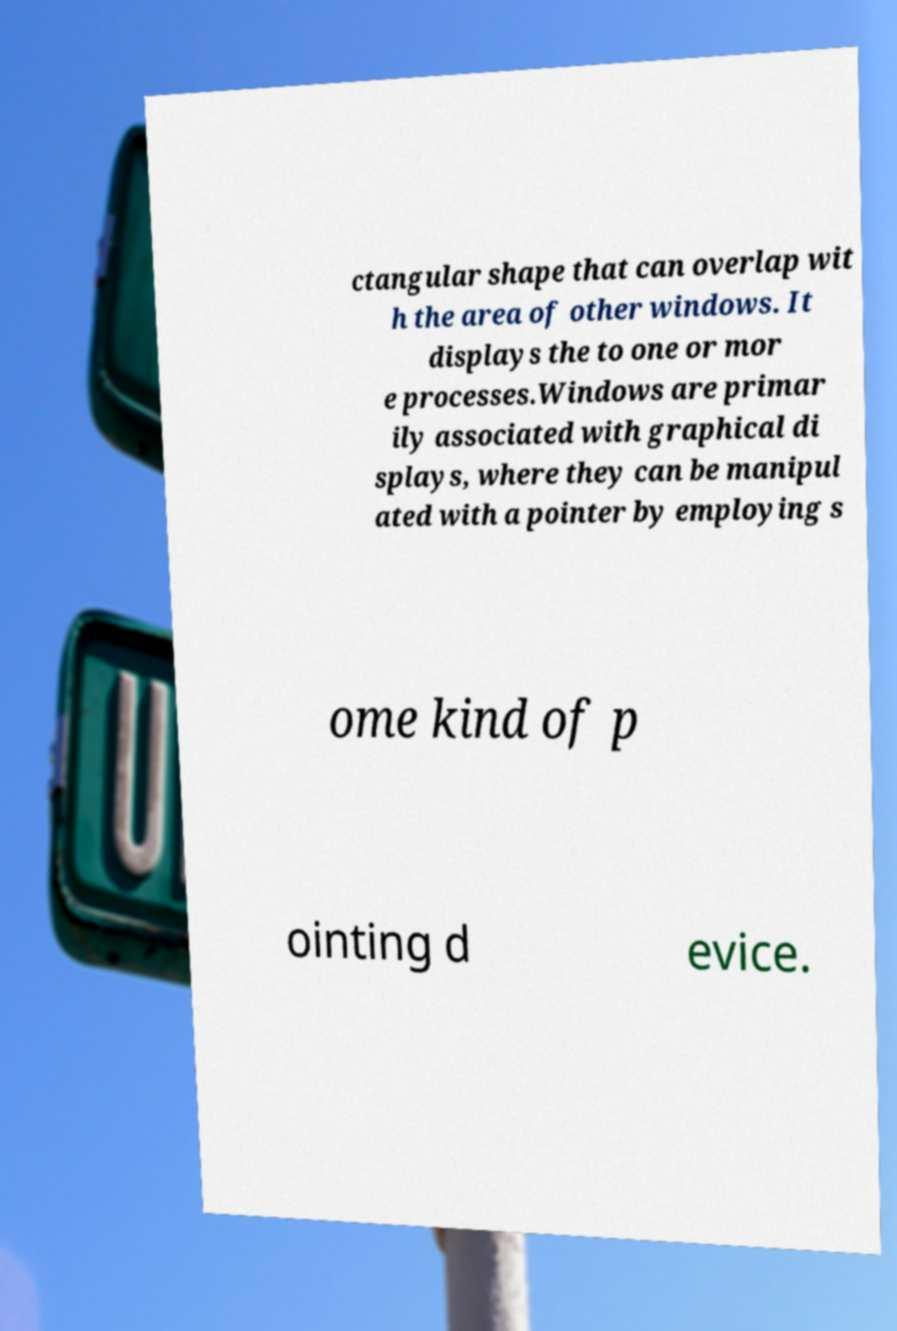Please read and relay the text visible in this image. What does it say? ctangular shape that can overlap wit h the area of other windows. It displays the to one or mor e processes.Windows are primar ily associated with graphical di splays, where they can be manipul ated with a pointer by employing s ome kind of p ointing d evice. 